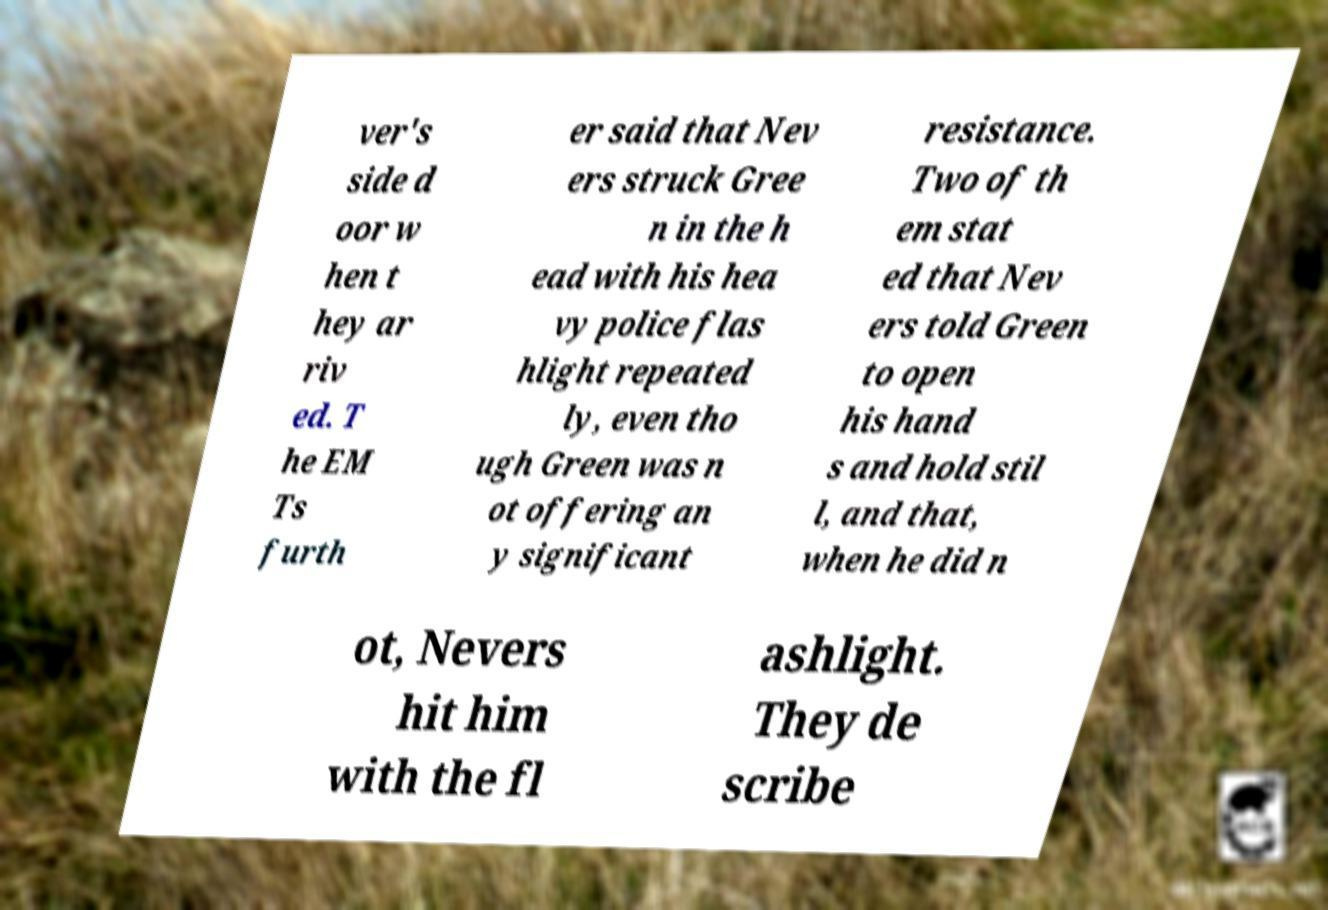Can you accurately transcribe the text from the provided image for me? ver's side d oor w hen t hey ar riv ed. T he EM Ts furth er said that Nev ers struck Gree n in the h ead with his hea vy police flas hlight repeated ly, even tho ugh Green was n ot offering an y significant resistance. Two of th em stat ed that Nev ers told Green to open his hand s and hold stil l, and that, when he did n ot, Nevers hit him with the fl ashlight. They de scribe 